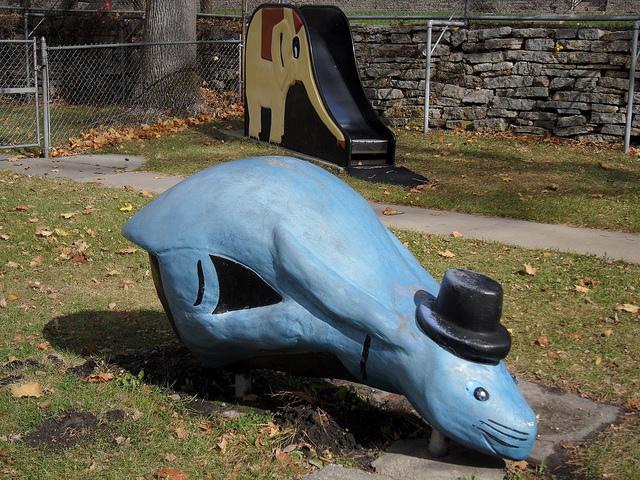Will this piece of equipment bounce?
Answer briefly. No. Is this for adults or children?
Concise answer only. Children. What kind of animal is this?
Give a very brief answer. Seal. 